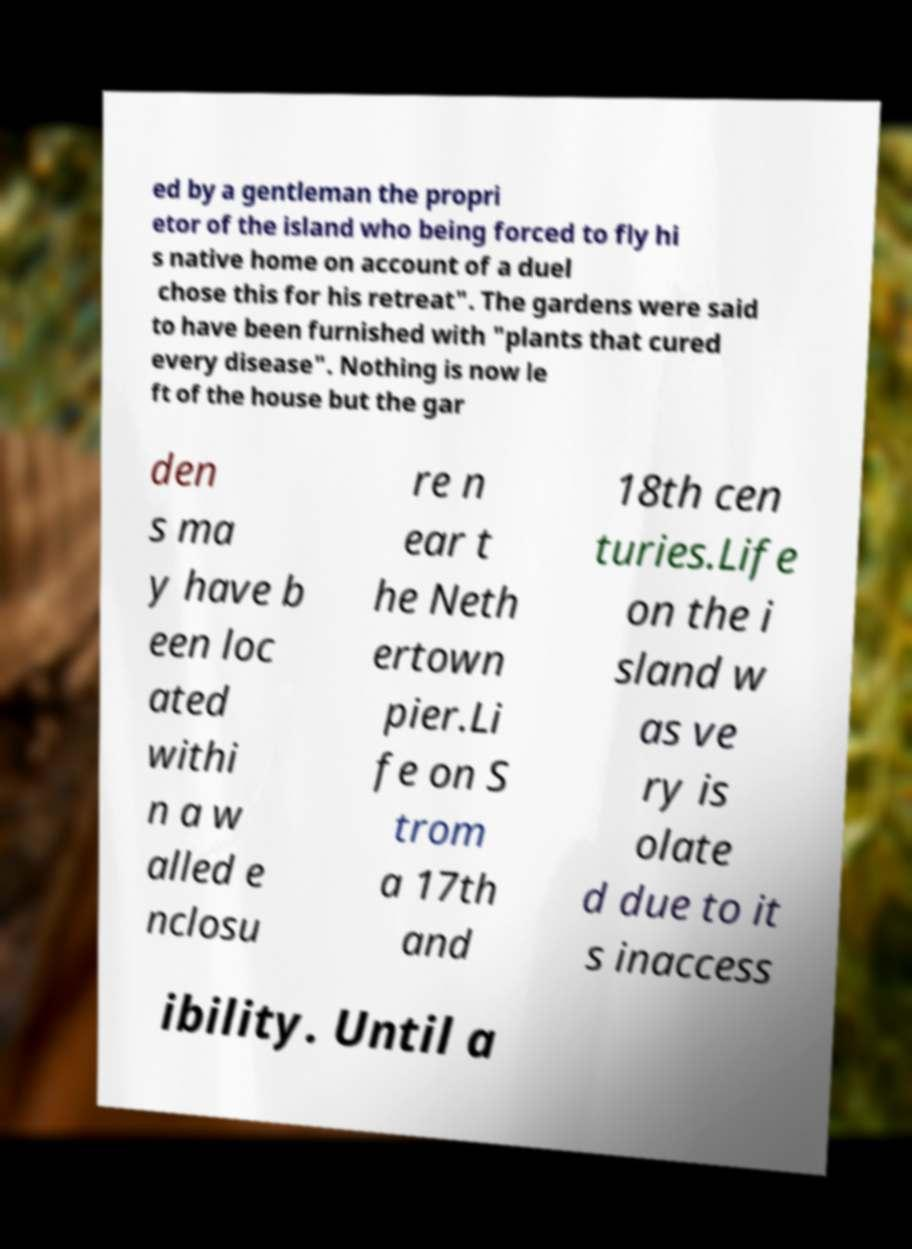For documentation purposes, I need the text within this image transcribed. Could you provide that? ed by a gentleman the propri etor of the island who being forced to fly hi s native home on account of a duel chose this for his retreat". The gardens were said to have been furnished with "plants that cured every disease". Nothing is now le ft of the house but the gar den s ma y have b een loc ated withi n a w alled e nclosu re n ear t he Neth ertown pier.Li fe on S trom a 17th and 18th cen turies.Life on the i sland w as ve ry is olate d due to it s inaccess ibility. Until a 